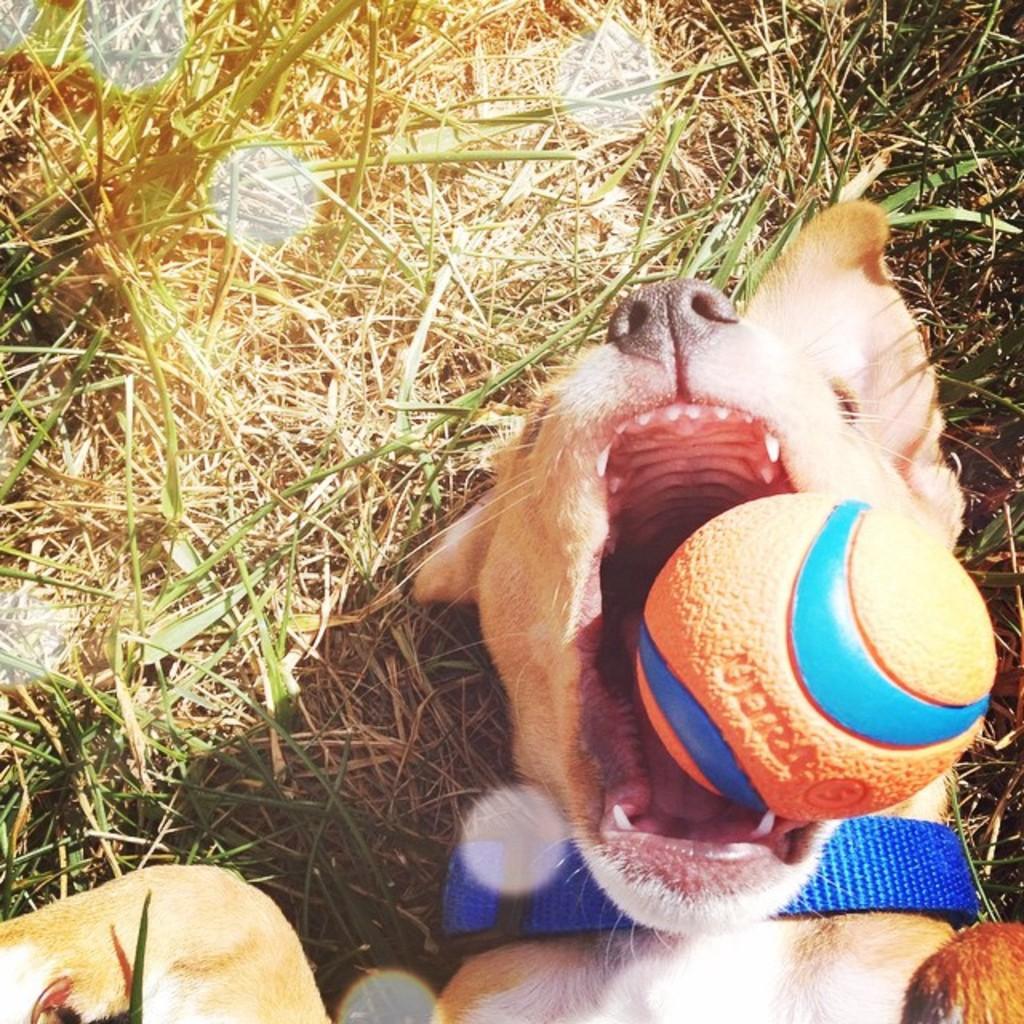How would you summarize this image in a sentence or two? Here we can see a dog and there is a ball near its mouth. In the background we can see grass. 